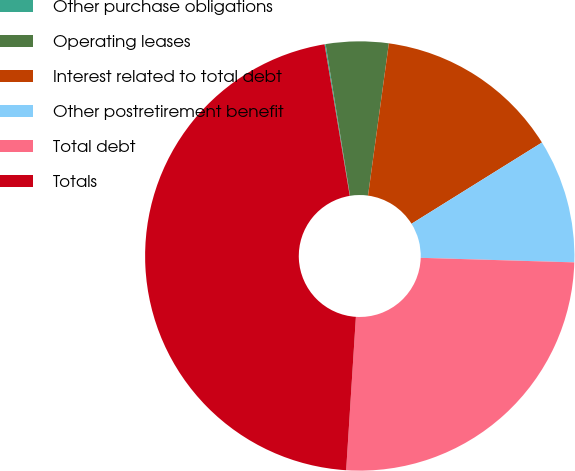<chart> <loc_0><loc_0><loc_500><loc_500><pie_chart><fcel>Other purchase obligations<fcel>Operating leases<fcel>Interest related to total debt<fcel>Other postretirement benefit<fcel>Total debt<fcel>Totals<nl><fcel>0.08%<fcel>4.71%<fcel>13.97%<fcel>9.34%<fcel>25.54%<fcel>46.37%<nl></chart> 